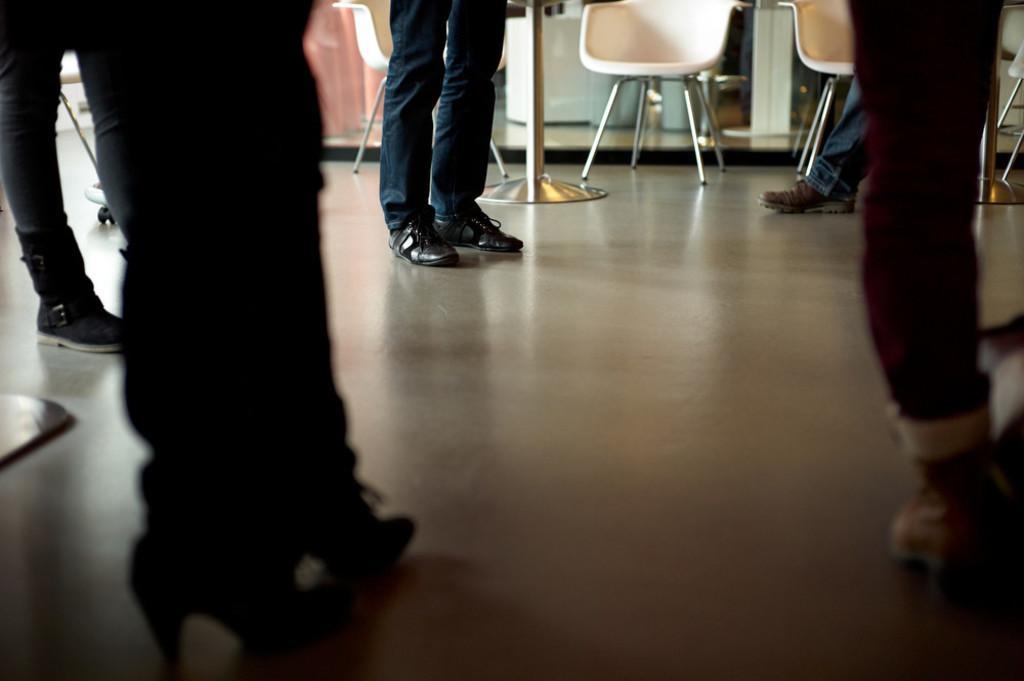Can you describe this image briefly? In the image we can see there are people who are standing on the floor and there are chairs at the back. 